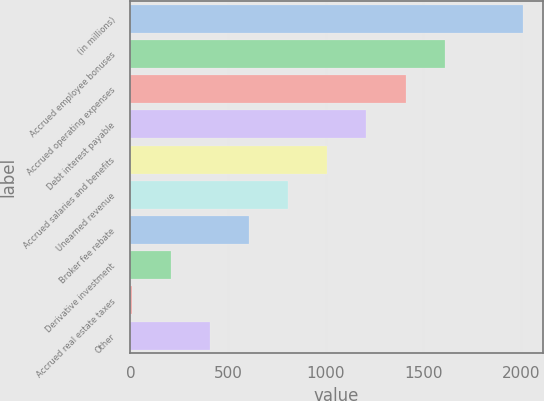Convert chart to OTSL. <chart><loc_0><loc_0><loc_500><loc_500><bar_chart><fcel>(in millions)<fcel>Accrued employee bonuses<fcel>Accrued operating expenses<fcel>Debt interest payable<fcel>Accrued salaries and benefits<fcel>Unearned revenue<fcel>Broker fee rebate<fcel>Derivative investment<fcel>Accrued real estate taxes<fcel>Other<nl><fcel>2010<fcel>1609.24<fcel>1408.86<fcel>1208.48<fcel>1008.1<fcel>807.72<fcel>607.34<fcel>206.58<fcel>6.2<fcel>406.96<nl></chart> 